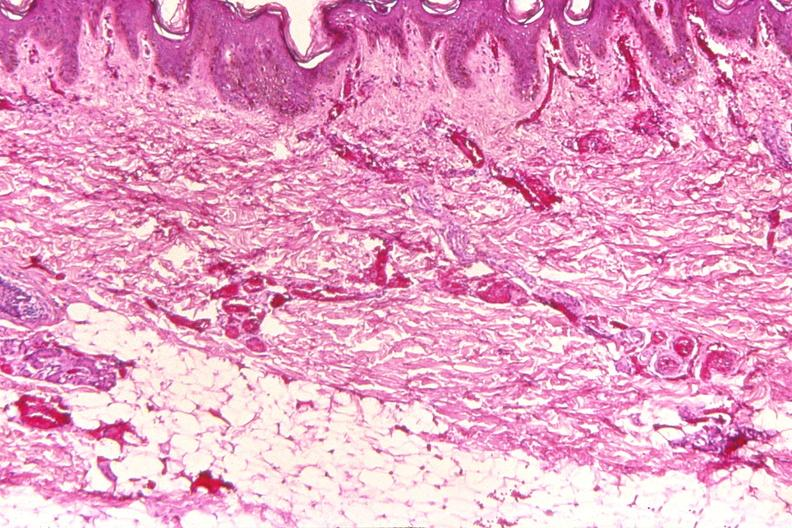where is this?
Answer the question using a single word or phrase. Skin 